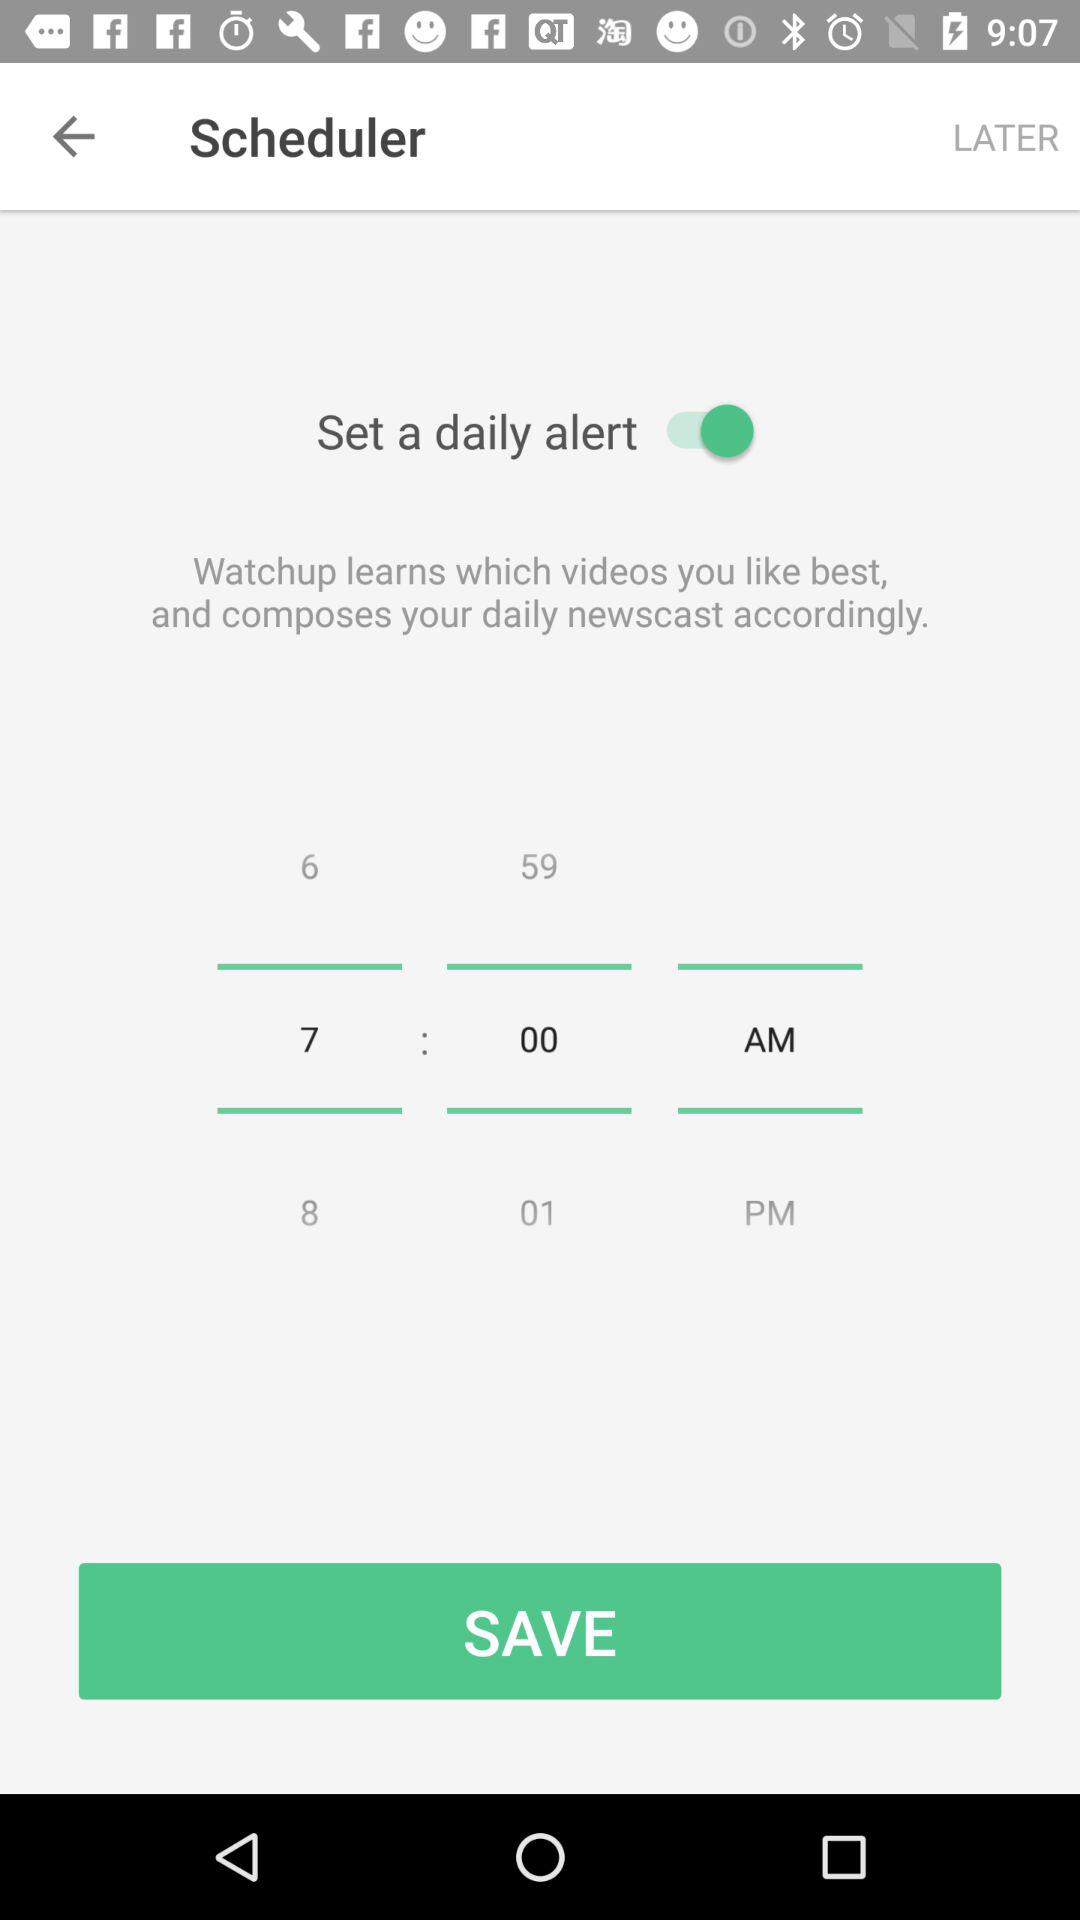What time did the scheduler set? The scheduler set the time for 7:00 a.m. 